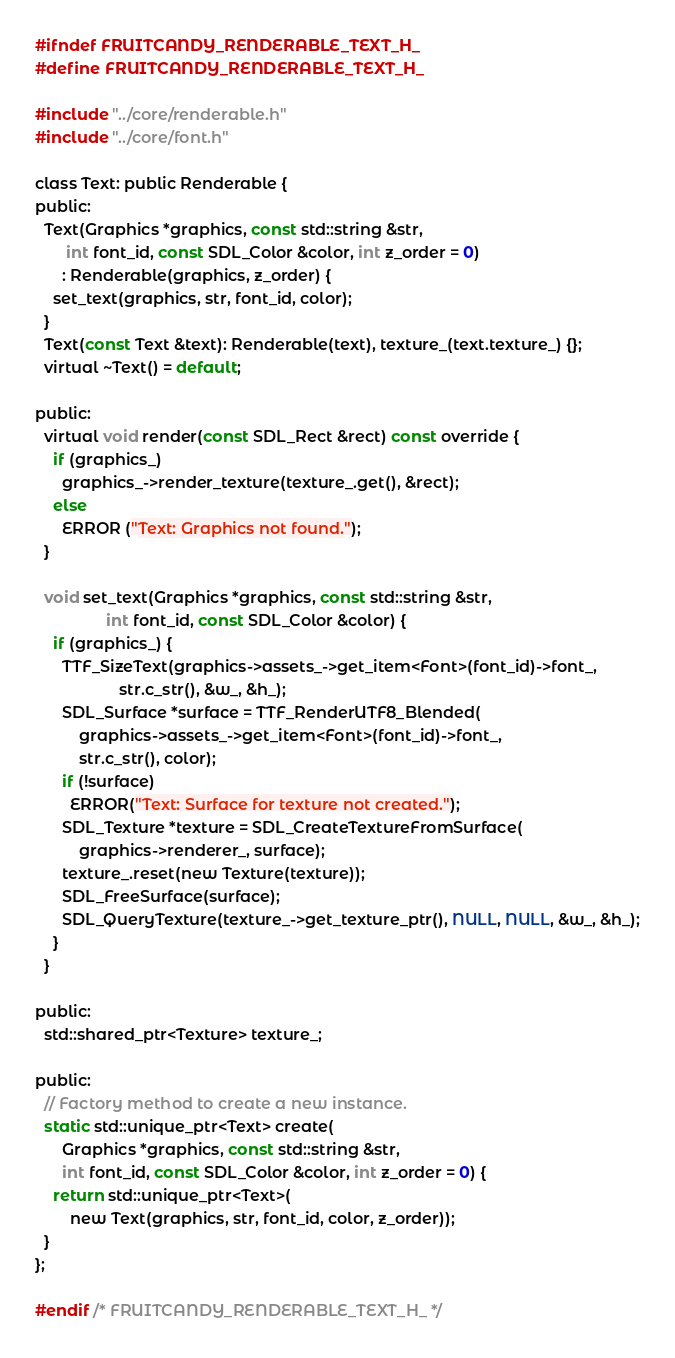Convert code to text. <code><loc_0><loc_0><loc_500><loc_500><_C_>#ifndef FRUITCANDY_RENDERABLE_TEXT_H_
#define FRUITCANDY_RENDERABLE_TEXT_H_

#include "../core/renderable.h"
#include "../core/font.h"

class Text: public Renderable {
public:
  Text(Graphics *graphics, const std::string &str,
       int font_id, const SDL_Color &color, int z_order = 0)
      : Renderable(graphics, z_order) {
    set_text(graphics, str, font_id, color);
  }
  Text(const Text &text): Renderable(text), texture_(text.texture_) {};
  virtual ~Text() = default;

public:
  virtual void render(const SDL_Rect &rect) const override {
    if (graphics_)
      graphics_->render_texture(texture_.get(), &rect);
    else
      ERROR ("Text: Graphics not found.");
  }

  void set_text(Graphics *graphics, const std::string &str,
                int font_id, const SDL_Color &color) {
    if (graphics_) {
      TTF_SizeText(graphics->assets_->get_item<Font>(font_id)->font_,
                   str.c_str(), &w_, &h_);
      SDL_Surface *surface = TTF_RenderUTF8_Blended(
          graphics->assets_->get_item<Font>(font_id)->font_,
          str.c_str(), color);
      if (!surface)
      	ERROR("Text: Surface for texture not created.");
      SDL_Texture *texture = SDL_CreateTextureFromSurface(
          graphics->renderer_, surface);
      texture_.reset(new Texture(texture));
      SDL_FreeSurface(surface);
      SDL_QueryTexture(texture_->get_texture_ptr(), NULL, NULL, &w_, &h_);
    }
  }

public:
  std::shared_ptr<Texture> texture_;

public:
  // Factory method to create a new instance.
  static std::unique_ptr<Text> create(
      Graphics *graphics, const std::string &str,
      int font_id, const SDL_Color &color, int z_order = 0) {
    return std::unique_ptr<Text>(
        new Text(graphics, str, font_id, color, z_order));
  }
};

#endif /* FRUITCANDY_RENDERABLE_TEXT_H_ */
</code> 